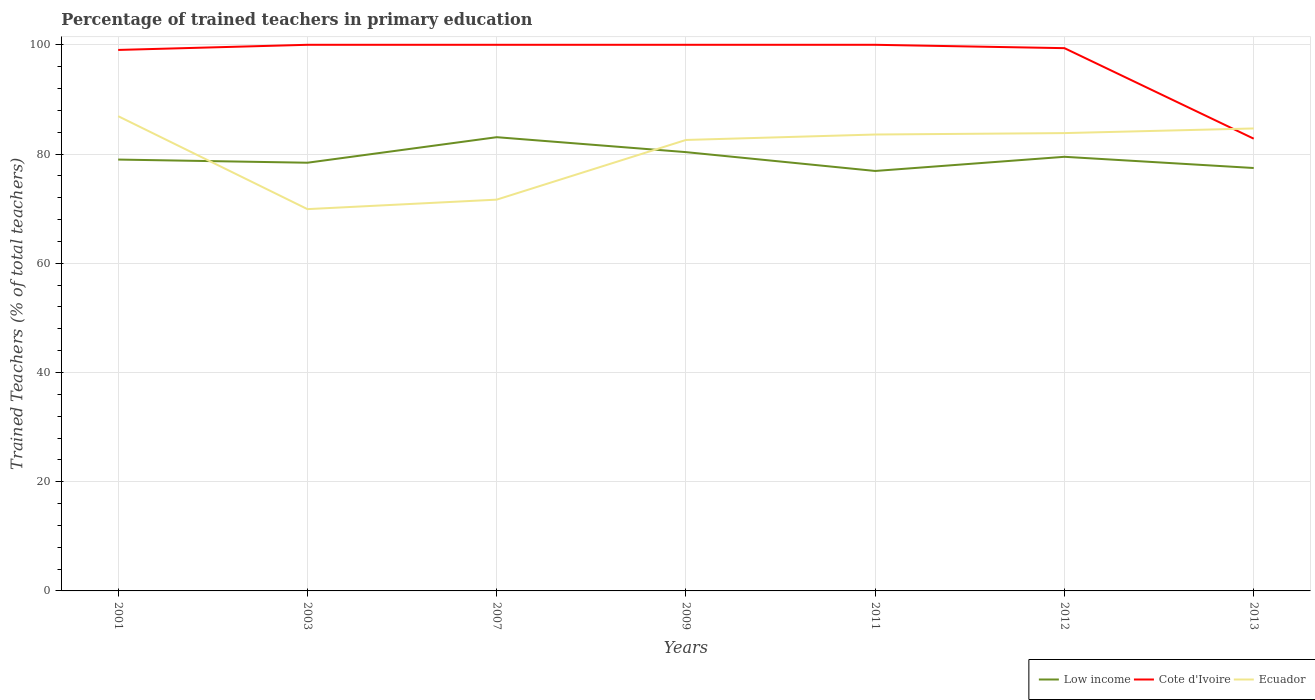Does the line corresponding to Ecuador intersect with the line corresponding to Cote d'Ivoire?
Provide a succinct answer. Yes. Is the number of lines equal to the number of legend labels?
Your answer should be very brief. Yes. Across all years, what is the maximum percentage of trained teachers in Low income?
Your response must be concise. 76.9. What is the total percentage of trained teachers in Ecuador in the graph?
Provide a succinct answer. -10.93. What is the difference between the highest and the second highest percentage of trained teachers in Cote d'Ivoire?
Your answer should be compact. 17.19. What is the difference between the highest and the lowest percentage of trained teachers in Low income?
Provide a succinct answer. 3. Is the percentage of trained teachers in Ecuador strictly greater than the percentage of trained teachers in Low income over the years?
Your answer should be very brief. No. How many years are there in the graph?
Make the answer very short. 7. Are the values on the major ticks of Y-axis written in scientific E-notation?
Provide a short and direct response. No. Does the graph contain any zero values?
Your answer should be compact. No. How are the legend labels stacked?
Ensure brevity in your answer.  Horizontal. What is the title of the graph?
Make the answer very short. Percentage of trained teachers in primary education. Does "Caribbean small states" appear as one of the legend labels in the graph?
Give a very brief answer. No. What is the label or title of the Y-axis?
Provide a succinct answer. Trained Teachers (% of total teachers). What is the Trained Teachers (% of total teachers) in Low income in 2001?
Offer a very short reply. 78.98. What is the Trained Teachers (% of total teachers) of Cote d'Ivoire in 2001?
Give a very brief answer. 99.06. What is the Trained Teachers (% of total teachers) of Ecuador in 2001?
Provide a short and direct response. 86.93. What is the Trained Teachers (% of total teachers) in Low income in 2003?
Give a very brief answer. 78.41. What is the Trained Teachers (% of total teachers) in Cote d'Ivoire in 2003?
Give a very brief answer. 100. What is the Trained Teachers (% of total teachers) of Ecuador in 2003?
Provide a short and direct response. 69.91. What is the Trained Teachers (% of total teachers) of Low income in 2007?
Offer a very short reply. 83.08. What is the Trained Teachers (% of total teachers) of Ecuador in 2007?
Keep it short and to the point. 71.65. What is the Trained Teachers (% of total teachers) in Low income in 2009?
Provide a succinct answer. 80.35. What is the Trained Teachers (% of total teachers) in Cote d'Ivoire in 2009?
Provide a succinct answer. 100. What is the Trained Teachers (% of total teachers) of Ecuador in 2009?
Keep it short and to the point. 82.57. What is the Trained Teachers (% of total teachers) in Low income in 2011?
Offer a very short reply. 76.9. What is the Trained Teachers (% of total teachers) of Cote d'Ivoire in 2011?
Offer a very short reply. 100. What is the Trained Teachers (% of total teachers) of Ecuador in 2011?
Provide a succinct answer. 83.57. What is the Trained Teachers (% of total teachers) of Low income in 2012?
Make the answer very short. 79.49. What is the Trained Teachers (% of total teachers) in Cote d'Ivoire in 2012?
Make the answer very short. 99.38. What is the Trained Teachers (% of total teachers) of Ecuador in 2012?
Your answer should be very brief. 83.83. What is the Trained Teachers (% of total teachers) in Low income in 2013?
Provide a short and direct response. 77.44. What is the Trained Teachers (% of total teachers) of Cote d'Ivoire in 2013?
Your answer should be very brief. 82.81. What is the Trained Teachers (% of total teachers) of Ecuador in 2013?
Offer a terse response. 84.68. Across all years, what is the maximum Trained Teachers (% of total teachers) in Low income?
Provide a succinct answer. 83.08. Across all years, what is the maximum Trained Teachers (% of total teachers) of Ecuador?
Your answer should be very brief. 86.93. Across all years, what is the minimum Trained Teachers (% of total teachers) in Low income?
Your response must be concise. 76.9. Across all years, what is the minimum Trained Teachers (% of total teachers) in Cote d'Ivoire?
Ensure brevity in your answer.  82.81. Across all years, what is the minimum Trained Teachers (% of total teachers) of Ecuador?
Provide a short and direct response. 69.91. What is the total Trained Teachers (% of total teachers) of Low income in the graph?
Give a very brief answer. 554.64. What is the total Trained Teachers (% of total teachers) in Cote d'Ivoire in the graph?
Keep it short and to the point. 681.25. What is the total Trained Teachers (% of total teachers) in Ecuador in the graph?
Provide a short and direct response. 563.14. What is the difference between the Trained Teachers (% of total teachers) of Low income in 2001 and that in 2003?
Offer a very short reply. 0.58. What is the difference between the Trained Teachers (% of total teachers) in Cote d'Ivoire in 2001 and that in 2003?
Provide a short and direct response. -0.94. What is the difference between the Trained Teachers (% of total teachers) in Ecuador in 2001 and that in 2003?
Offer a terse response. 17.02. What is the difference between the Trained Teachers (% of total teachers) in Low income in 2001 and that in 2007?
Keep it short and to the point. -4.1. What is the difference between the Trained Teachers (% of total teachers) in Cote d'Ivoire in 2001 and that in 2007?
Offer a very short reply. -0.94. What is the difference between the Trained Teachers (% of total teachers) of Ecuador in 2001 and that in 2007?
Provide a short and direct response. 15.28. What is the difference between the Trained Teachers (% of total teachers) of Low income in 2001 and that in 2009?
Offer a terse response. -1.36. What is the difference between the Trained Teachers (% of total teachers) in Cote d'Ivoire in 2001 and that in 2009?
Offer a very short reply. -0.94. What is the difference between the Trained Teachers (% of total teachers) of Ecuador in 2001 and that in 2009?
Provide a succinct answer. 4.35. What is the difference between the Trained Teachers (% of total teachers) in Low income in 2001 and that in 2011?
Offer a terse response. 2.09. What is the difference between the Trained Teachers (% of total teachers) in Cote d'Ivoire in 2001 and that in 2011?
Your response must be concise. -0.94. What is the difference between the Trained Teachers (% of total teachers) of Ecuador in 2001 and that in 2011?
Provide a succinct answer. 3.36. What is the difference between the Trained Teachers (% of total teachers) in Low income in 2001 and that in 2012?
Ensure brevity in your answer.  -0.51. What is the difference between the Trained Teachers (% of total teachers) in Cote d'Ivoire in 2001 and that in 2012?
Keep it short and to the point. -0.33. What is the difference between the Trained Teachers (% of total teachers) in Ecuador in 2001 and that in 2012?
Give a very brief answer. 3.1. What is the difference between the Trained Teachers (% of total teachers) of Low income in 2001 and that in 2013?
Offer a terse response. 1.55. What is the difference between the Trained Teachers (% of total teachers) of Cote d'Ivoire in 2001 and that in 2013?
Your answer should be compact. 16.25. What is the difference between the Trained Teachers (% of total teachers) in Ecuador in 2001 and that in 2013?
Your answer should be very brief. 2.25. What is the difference between the Trained Teachers (% of total teachers) in Low income in 2003 and that in 2007?
Offer a terse response. -4.68. What is the difference between the Trained Teachers (% of total teachers) of Ecuador in 2003 and that in 2007?
Your response must be concise. -1.74. What is the difference between the Trained Teachers (% of total teachers) of Low income in 2003 and that in 2009?
Offer a terse response. -1.94. What is the difference between the Trained Teachers (% of total teachers) of Ecuador in 2003 and that in 2009?
Offer a very short reply. -12.66. What is the difference between the Trained Teachers (% of total teachers) of Low income in 2003 and that in 2011?
Offer a terse response. 1.51. What is the difference between the Trained Teachers (% of total teachers) of Cote d'Ivoire in 2003 and that in 2011?
Your response must be concise. 0. What is the difference between the Trained Teachers (% of total teachers) in Ecuador in 2003 and that in 2011?
Keep it short and to the point. -13.66. What is the difference between the Trained Teachers (% of total teachers) of Low income in 2003 and that in 2012?
Provide a short and direct response. -1.09. What is the difference between the Trained Teachers (% of total teachers) of Cote d'Ivoire in 2003 and that in 2012?
Your answer should be compact. 0.62. What is the difference between the Trained Teachers (% of total teachers) in Ecuador in 2003 and that in 2012?
Offer a terse response. -13.92. What is the difference between the Trained Teachers (% of total teachers) in Low income in 2003 and that in 2013?
Make the answer very short. 0.97. What is the difference between the Trained Teachers (% of total teachers) in Cote d'Ivoire in 2003 and that in 2013?
Your answer should be very brief. 17.19. What is the difference between the Trained Teachers (% of total teachers) in Ecuador in 2003 and that in 2013?
Your answer should be compact. -14.77. What is the difference between the Trained Teachers (% of total teachers) of Low income in 2007 and that in 2009?
Offer a very short reply. 2.74. What is the difference between the Trained Teachers (% of total teachers) in Ecuador in 2007 and that in 2009?
Make the answer very short. -10.93. What is the difference between the Trained Teachers (% of total teachers) in Low income in 2007 and that in 2011?
Your response must be concise. 6.18. What is the difference between the Trained Teachers (% of total teachers) in Cote d'Ivoire in 2007 and that in 2011?
Make the answer very short. 0. What is the difference between the Trained Teachers (% of total teachers) in Ecuador in 2007 and that in 2011?
Offer a terse response. -11.93. What is the difference between the Trained Teachers (% of total teachers) of Low income in 2007 and that in 2012?
Make the answer very short. 3.59. What is the difference between the Trained Teachers (% of total teachers) of Cote d'Ivoire in 2007 and that in 2012?
Your response must be concise. 0.62. What is the difference between the Trained Teachers (% of total teachers) of Ecuador in 2007 and that in 2012?
Your response must be concise. -12.19. What is the difference between the Trained Teachers (% of total teachers) in Low income in 2007 and that in 2013?
Ensure brevity in your answer.  5.64. What is the difference between the Trained Teachers (% of total teachers) of Cote d'Ivoire in 2007 and that in 2013?
Provide a succinct answer. 17.19. What is the difference between the Trained Teachers (% of total teachers) in Ecuador in 2007 and that in 2013?
Make the answer very short. -13.04. What is the difference between the Trained Teachers (% of total teachers) in Low income in 2009 and that in 2011?
Ensure brevity in your answer.  3.45. What is the difference between the Trained Teachers (% of total teachers) in Ecuador in 2009 and that in 2011?
Your answer should be compact. -1. What is the difference between the Trained Teachers (% of total teachers) in Low income in 2009 and that in 2012?
Provide a short and direct response. 0.85. What is the difference between the Trained Teachers (% of total teachers) of Cote d'Ivoire in 2009 and that in 2012?
Your answer should be very brief. 0.62. What is the difference between the Trained Teachers (% of total teachers) of Ecuador in 2009 and that in 2012?
Provide a succinct answer. -1.26. What is the difference between the Trained Teachers (% of total teachers) in Low income in 2009 and that in 2013?
Make the answer very short. 2.91. What is the difference between the Trained Teachers (% of total teachers) of Cote d'Ivoire in 2009 and that in 2013?
Provide a short and direct response. 17.19. What is the difference between the Trained Teachers (% of total teachers) of Ecuador in 2009 and that in 2013?
Ensure brevity in your answer.  -2.11. What is the difference between the Trained Teachers (% of total teachers) in Low income in 2011 and that in 2012?
Provide a short and direct response. -2.59. What is the difference between the Trained Teachers (% of total teachers) of Cote d'Ivoire in 2011 and that in 2012?
Make the answer very short. 0.62. What is the difference between the Trained Teachers (% of total teachers) in Ecuador in 2011 and that in 2012?
Your answer should be compact. -0.26. What is the difference between the Trained Teachers (% of total teachers) of Low income in 2011 and that in 2013?
Provide a succinct answer. -0.54. What is the difference between the Trained Teachers (% of total teachers) of Cote d'Ivoire in 2011 and that in 2013?
Ensure brevity in your answer.  17.19. What is the difference between the Trained Teachers (% of total teachers) in Ecuador in 2011 and that in 2013?
Ensure brevity in your answer.  -1.11. What is the difference between the Trained Teachers (% of total teachers) in Low income in 2012 and that in 2013?
Ensure brevity in your answer.  2.05. What is the difference between the Trained Teachers (% of total teachers) of Cote d'Ivoire in 2012 and that in 2013?
Make the answer very short. 16.58. What is the difference between the Trained Teachers (% of total teachers) of Ecuador in 2012 and that in 2013?
Your answer should be compact. -0.85. What is the difference between the Trained Teachers (% of total teachers) of Low income in 2001 and the Trained Teachers (% of total teachers) of Cote d'Ivoire in 2003?
Your response must be concise. -21.02. What is the difference between the Trained Teachers (% of total teachers) in Low income in 2001 and the Trained Teachers (% of total teachers) in Ecuador in 2003?
Keep it short and to the point. 9.07. What is the difference between the Trained Teachers (% of total teachers) in Cote d'Ivoire in 2001 and the Trained Teachers (% of total teachers) in Ecuador in 2003?
Offer a terse response. 29.15. What is the difference between the Trained Teachers (% of total teachers) in Low income in 2001 and the Trained Teachers (% of total teachers) in Cote d'Ivoire in 2007?
Make the answer very short. -21.02. What is the difference between the Trained Teachers (% of total teachers) of Low income in 2001 and the Trained Teachers (% of total teachers) of Ecuador in 2007?
Give a very brief answer. 7.34. What is the difference between the Trained Teachers (% of total teachers) of Cote d'Ivoire in 2001 and the Trained Teachers (% of total teachers) of Ecuador in 2007?
Offer a terse response. 27.41. What is the difference between the Trained Teachers (% of total teachers) of Low income in 2001 and the Trained Teachers (% of total teachers) of Cote d'Ivoire in 2009?
Give a very brief answer. -21.02. What is the difference between the Trained Teachers (% of total teachers) in Low income in 2001 and the Trained Teachers (% of total teachers) in Ecuador in 2009?
Your answer should be very brief. -3.59. What is the difference between the Trained Teachers (% of total teachers) in Cote d'Ivoire in 2001 and the Trained Teachers (% of total teachers) in Ecuador in 2009?
Offer a very short reply. 16.48. What is the difference between the Trained Teachers (% of total teachers) of Low income in 2001 and the Trained Teachers (% of total teachers) of Cote d'Ivoire in 2011?
Offer a very short reply. -21.02. What is the difference between the Trained Teachers (% of total teachers) of Low income in 2001 and the Trained Teachers (% of total teachers) of Ecuador in 2011?
Provide a succinct answer. -4.59. What is the difference between the Trained Teachers (% of total teachers) in Cote d'Ivoire in 2001 and the Trained Teachers (% of total teachers) in Ecuador in 2011?
Give a very brief answer. 15.48. What is the difference between the Trained Teachers (% of total teachers) of Low income in 2001 and the Trained Teachers (% of total teachers) of Cote d'Ivoire in 2012?
Provide a succinct answer. -20.4. What is the difference between the Trained Teachers (% of total teachers) in Low income in 2001 and the Trained Teachers (% of total teachers) in Ecuador in 2012?
Your response must be concise. -4.85. What is the difference between the Trained Teachers (% of total teachers) of Cote d'Ivoire in 2001 and the Trained Teachers (% of total teachers) of Ecuador in 2012?
Offer a terse response. 15.23. What is the difference between the Trained Teachers (% of total teachers) of Low income in 2001 and the Trained Teachers (% of total teachers) of Cote d'Ivoire in 2013?
Make the answer very short. -3.82. What is the difference between the Trained Teachers (% of total teachers) in Low income in 2001 and the Trained Teachers (% of total teachers) in Ecuador in 2013?
Provide a short and direct response. -5.7. What is the difference between the Trained Teachers (% of total teachers) in Cote d'Ivoire in 2001 and the Trained Teachers (% of total teachers) in Ecuador in 2013?
Your answer should be very brief. 14.38. What is the difference between the Trained Teachers (% of total teachers) in Low income in 2003 and the Trained Teachers (% of total teachers) in Cote d'Ivoire in 2007?
Give a very brief answer. -21.59. What is the difference between the Trained Teachers (% of total teachers) of Low income in 2003 and the Trained Teachers (% of total teachers) of Ecuador in 2007?
Your answer should be compact. 6.76. What is the difference between the Trained Teachers (% of total teachers) of Cote d'Ivoire in 2003 and the Trained Teachers (% of total teachers) of Ecuador in 2007?
Offer a very short reply. 28.35. What is the difference between the Trained Teachers (% of total teachers) in Low income in 2003 and the Trained Teachers (% of total teachers) in Cote d'Ivoire in 2009?
Keep it short and to the point. -21.59. What is the difference between the Trained Teachers (% of total teachers) in Low income in 2003 and the Trained Teachers (% of total teachers) in Ecuador in 2009?
Your answer should be very brief. -4.17. What is the difference between the Trained Teachers (% of total teachers) of Cote d'Ivoire in 2003 and the Trained Teachers (% of total teachers) of Ecuador in 2009?
Ensure brevity in your answer.  17.43. What is the difference between the Trained Teachers (% of total teachers) of Low income in 2003 and the Trained Teachers (% of total teachers) of Cote d'Ivoire in 2011?
Keep it short and to the point. -21.59. What is the difference between the Trained Teachers (% of total teachers) in Low income in 2003 and the Trained Teachers (% of total teachers) in Ecuador in 2011?
Make the answer very short. -5.17. What is the difference between the Trained Teachers (% of total teachers) in Cote d'Ivoire in 2003 and the Trained Teachers (% of total teachers) in Ecuador in 2011?
Your response must be concise. 16.43. What is the difference between the Trained Teachers (% of total teachers) in Low income in 2003 and the Trained Teachers (% of total teachers) in Cote d'Ivoire in 2012?
Make the answer very short. -20.98. What is the difference between the Trained Teachers (% of total teachers) in Low income in 2003 and the Trained Teachers (% of total teachers) in Ecuador in 2012?
Your answer should be compact. -5.43. What is the difference between the Trained Teachers (% of total teachers) in Cote d'Ivoire in 2003 and the Trained Teachers (% of total teachers) in Ecuador in 2012?
Your response must be concise. 16.17. What is the difference between the Trained Teachers (% of total teachers) of Low income in 2003 and the Trained Teachers (% of total teachers) of Cote d'Ivoire in 2013?
Offer a very short reply. -4.4. What is the difference between the Trained Teachers (% of total teachers) of Low income in 2003 and the Trained Teachers (% of total teachers) of Ecuador in 2013?
Your answer should be compact. -6.28. What is the difference between the Trained Teachers (% of total teachers) of Cote d'Ivoire in 2003 and the Trained Teachers (% of total teachers) of Ecuador in 2013?
Ensure brevity in your answer.  15.32. What is the difference between the Trained Teachers (% of total teachers) of Low income in 2007 and the Trained Teachers (% of total teachers) of Cote d'Ivoire in 2009?
Provide a succinct answer. -16.92. What is the difference between the Trained Teachers (% of total teachers) of Low income in 2007 and the Trained Teachers (% of total teachers) of Ecuador in 2009?
Make the answer very short. 0.51. What is the difference between the Trained Teachers (% of total teachers) in Cote d'Ivoire in 2007 and the Trained Teachers (% of total teachers) in Ecuador in 2009?
Provide a succinct answer. 17.43. What is the difference between the Trained Teachers (% of total teachers) in Low income in 2007 and the Trained Teachers (% of total teachers) in Cote d'Ivoire in 2011?
Provide a succinct answer. -16.92. What is the difference between the Trained Teachers (% of total teachers) of Low income in 2007 and the Trained Teachers (% of total teachers) of Ecuador in 2011?
Your answer should be very brief. -0.49. What is the difference between the Trained Teachers (% of total teachers) in Cote d'Ivoire in 2007 and the Trained Teachers (% of total teachers) in Ecuador in 2011?
Give a very brief answer. 16.43. What is the difference between the Trained Teachers (% of total teachers) of Low income in 2007 and the Trained Teachers (% of total teachers) of Cote d'Ivoire in 2012?
Provide a succinct answer. -16.3. What is the difference between the Trained Teachers (% of total teachers) in Low income in 2007 and the Trained Teachers (% of total teachers) in Ecuador in 2012?
Provide a short and direct response. -0.75. What is the difference between the Trained Teachers (% of total teachers) in Cote d'Ivoire in 2007 and the Trained Teachers (% of total teachers) in Ecuador in 2012?
Offer a very short reply. 16.17. What is the difference between the Trained Teachers (% of total teachers) in Low income in 2007 and the Trained Teachers (% of total teachers) in Cote d'Ivoire in 2013?
Ensure brevity in your answer.  0.27. What is the difference between the Trained Teachers (% of total teachers) in Low income in 2007 and the Trained Teachers (% of total teachers) in Ecuador in 2013?
Your answer should be compact. -1.6. What is the difference between the Trained Teachers (% of total teachers) of Cote d'Ivoire in 2007 and the Trained Teachers (% of total teachers) of Ecuador in 2013?
Make the answer very short. 15.32. What is the difference between the Trained Teachers (% of total teachers) of Low income in 2009 and the Trained Teachers (% of total teachers) of Cote d'Ivoire in 2011?
Your answer should be very brief. -19.65. What is the difference between the Trained Teachers (% of total teachers) of Low income in 2009 and the Trained Teachers (% of total teachers) of Ecuador in 2011?
Offer a terse response. -3.23. What is the difference between the Trained Teachers (% of total teachers) of Cote d'Ivoire in 2009 and the Trained Teachers (% of total teachers) of Ecuador in 2011?
Keep it short and to the point. 16.43. What is the difference between the Trained Teachers (% of total teachers) of Low income in 2009 and the Trained Teachers (% of total teachers) of Cote d'Ivoire in 2012?
Give a very brief answer. -19.04. What is the difference between the Trained Teachers (% of total teachers) in Low income in 2009 and the Trained Teachers (% of total teachers) in Ecuador in 2012?
Offer a very short reply. -3.49. What is the difference between the Trained Teachers (% of total teachers) in Cote d'Ivoire in 2009 and the Trained Teachers (% of total teachers) in Ecuador in 2012?
Ensure brevity in your answer.  16.17. What is the difference between the Trained Teachers (% of total teachers) of Low income in 2009 and the Trained Teachers (% of total teachers) of Cote d'Ivoire in 2013?
Ensure brevity in your answer.  -2.46. What is the difference between the Trained Teachers (% of total teachers) in Low income in 2009 and the Trained Teachers (% of total teachers) in Ecuador in 2013?
Your answer should be very brief. -4.34. What is the difference between the Trained Teachers (% of total teachers) of Cote d'Ivoire in 2009 and the Trained Teachers (% of total teachers) of Ecuador in 2013?
Your answer should be compact. 15.32. What is the difference between the Trained Teachers (% of total teachers) in Low income in 2011 and the Trained Teachers (% of total teachers) in Cote d'Ivoire in 2012?
Ensure brevity in your answer.  -22.49. What is the difference between the Trained Teachers (% of total teachers) in Low income in 2011 and the Trained Teachers (% of total teachers) in Ecuador in 2012?
Your response must be concise. -6.93. What is the difference between the Trained Teachers (% of total teachers) in Cote d'Ivoire in 2011 and the Trained Teachers (% of total teachers) in Ecuador in 2012?
Your response must be concise. 16.17. What is the difference between the Trained Teachers (% of total teachers) of Low income in 2011 and the Trained Teachers (% of total teachers) of Cote d'Ivoire in 2013?
Your answer should be compact. -5.91. What is the difference between the Trained Teachers (% of total teachers) of Low income in 2011 and the Trained Teachers (% of total teachers) of Ecuador in 2013?
Make the answer very short. -7.78. What is the difference between the Trained Teachers (% of total teachers) in Cote d'Ivoire in 2011 and the Trained Teachers (% of total teachers) in Ecuador in 2013?
Your answer should be very brief. 15.32. What is the difference between the Trained Teachers (% of total teachers) in Low income in 2012 and the Trained Teachers (% of total teachers) in Cote d'Ivoire in 2013?
Provide a short and direct response. -3.32. What is the difference between the Trained Teachers (% of total teachers) of Low income in 2012 and the Trained Teachers (% of total teachers) of Ecuador in 2013?
Provide a short and direct response. -5.19. What is the difference between the Trained Teachers (% of total teachers) of Cote d'Ivoire in 2012 and the Trained Teachers (% of total teachers) of Ecuador in 2013?
Ensure brevity in your answer.  14.7. What is the average Trained Teachers (% of total teachers) of Low income per year?
Offer a very short reply. 79.23. What is the average Trained Teachers (% of total teachers) of Cote d'Ivoire per year?
Your answer should be very brief. 97.32. What is the average Trained Teachers (% of total teachers) of Ecuador per year?
Make the answer very short. 80.45. In the year 2001, what is the difference between the Trained Teachers (% of total teachers) in Low income and Trained Teachers (% of total teachers) in Cote d'Ivoire?
Offer a very short reply. -20.07. In the year 2001, what is the difference between the Trained Teachers (% of total teachers) of Low income and Trained Teachers (% of total teachers) of Ecuador?
Offer a terse response. -7.94. In the year 2001, what is the difference between the Trained Teachers (% of total teachers) of Cote d'Ivoire and Trained Teachers (% of total teachers) of Ecuador?
Your answer should be compact. 12.13. In the year 2003, what is the difference between the Trained Teachers (% of total teachers) in Low income and Trained Teachers (% of total teachers) in Cote d'Ivoire?
Ensure brevity in your answer.  -21.59. In the year 2003, what is the difference between the Trained Teachers (% of total teachers) in Low income and Trained Teachers (% of total teachers) in Ecuador?
Your answer should be compact. 8.5. In the year 2003, what is the difference between the Trained Teachers (% of total teachers) in Cote d'Ivoire and Trained Teachers (% of total teachers) in Ecuador?
Provide a succinct answer. 30.09. In the year 2007, what is the difference between the Trained Teachers (% of total teachers) in Low income and Trained Teachers (% of total teachers) in Cote d'Ivoire?
Your response must be concise. -16.92. In the year 2007, what is the difference between the Trained Teachers (% of total teachers) of Low income and Trained Teachers (% of total teachers) of Ecuador?
Your response must be concise. 11.44. In the year 2007, what is the difference between the Trained Teachers (% of total teachers) in Cote d'Ivoire and Trained Teachers (% of total teachers) in Ecuador?
Provide a short and direct response. 28.35. In the year 2009, what is the difference between the Trained Teachers (% of total teachers) in Low income and Trained Teachers (% of total teachers) in Cote d'Ivoire?
Provide a succinct answer. -19.65. In the year 2009, what is the difference between the Trained Teachers (% of total teachers) of Low income and Trained Teachers (% of total teachers) of Ecuador?
Make the answer very short. -2.23. In the year 2009, what is the difference between the Trained Teachers (% of total teachers) in Cote d'Ivoire and Trained Teachers (% of total teachers) in Ecuador?
Provide a succinct answer. 17.43. In the year 2011, what is the difference between the Trained Teachers (% of total teachers) of Low income and Trained Teachers (% of total teachers) of Cote d'Ivoire?
Ensure brevity in your answer.  -23.1. In the year 2011, what is the difference between the Trained Teachers (% of total teachers) in Low income and Trained Teachers (% of total teachers) in Ecuador?
Provide a short and direct response. -6.67. In the year 2011, what is the difference between the Trained Teachers (% of total teachers) in Cote d'Ivoire and Trained Teachers (% of total teachers) in Ecuador?
Make the answer very short. 16.43. In the year 2012, what is the difference between the Trained Teachers (% of total teachers) in Low income and Trained Teachers (% of total teachers) in Cote d'Ivoire?
Your answer should be very brief. -19.89. In the year 2012, what is the difference between the Trained Teachers (% of total teachers) of Low income and Trained Teachers (% of total teachers) of Ecuador?
Offer a very short reply. -4.34. In the year 2012, what is the difference between the Trained Teachers (% of total teachers) in Cote d'Ivoire and Trained Teachers (% of total teachers) in Ecuador?
Your answer should be compact. 15.55. In the year 2013, what is the difference between the Trained Teachers (% of total teachers) of Low income and Trained Teachers (% of total teachers) of Cote d'Ivoire?
Provide a succinct answer. -5.37. In the year 2013, what is the difference between the Trained Teachers (% of total teachers) of Low income and Trained Teachers (% of total teachers) of Ecuador?
Your answer should be compact. -7.24. In the year 2013, what is the difference between the Trained Teachers (% of total teachers) of Cote d'Ivoire and Trained Teachers (% of total teachers) of Ecuador?
Ensure brevity in your answer.  -1.87. What is the ratio of the Trained Teachers (% of total teachers) in Low income in 2001 to that in 2003?
Make the answer very short. 1.01. What is the ratio of the Trained Teachers (% of total teachers) of Cote d'Ivoire in 2001 to that in 2003?
Provide a succinct answer. 0.99. What is the ratio of the Trained Teachers (% of total teachers) in Ecuador in 2001 to that in 2003?
Offer a terse response. 1.24. What is the ratio of the Trained Teachers (% of total teachers) of Low income in 2001 to that in 2007?
Provide a succinct answer. 0.95. What is the ratio of the Trained Teachers (% of total teachers) of Cote d'Ivoire in 2001 to that in 2007?
Your answer should be compact. 0.99. What is the ratio of the Trained Teachers (% of total teachers) of Ecuador in 2001 to that in 2007?
Give a very brief answer. 1.21. What is the ratio of the Trained Teachers (% of total teachers) of Low income in 2001 to that in 2009?
Keep it short and to the point. 0.98. What is the ratio of the Trained Teachers (% of total teachers) of Cote d'Ivoire in 2001 to that in 2009?
Your answer should be compact. 0.99. What is the ratio of the Trained Teachers (% of total teachers) in Ecuador in 2001 to that in 2009?
Your response must be concise. 1.05. What is the ratio of the Trained Teachers (% of total teachers) in Low income in 2001 to that in 2011?
Ensure brevity in your answer.  1.03. What is the ratio of the Trained Teachers (% of total teachers) of Cote d'Ivoire in 2001 to that in 2011?
Give a very brief answer. 0.99. What is the ratio of the Trained Teachers (% of total teachers) of Ecuador in 2001 to that in 2011?
Ensure brevity in your answer.  1.04. What is the ratio of the Trained Teachers (% of total teachers) of Low income in 2001 to that in 2012?
Your answer should be very brief. 0.99. What is the ratio of the Trained Teachers (% of total teachers) of Cote d'Ivoire in 2001 to that in 2012?
Give a very brief answer. 1. What is the ratio of the Trained Teachers (% of total teachers) of Ecuador in 2001 to that in 2012?
Make the answer very short. 1.04. What is the ratio of the Trained Teachers (% of total teachers) of Cote d'Ivoire in 2001 to that in 2013?
Keep it short and to the point. 1.2. What is the ratio of the Trained Teachers (% of total teachers) in Ecuador in 2001 to that in 2013?
Make the answer very short. 1.03. What is the ratio of the Trained Teachers (% of total teachers) in Low income in 2003 to that in 2007?
Give a very brief answer. 0.94. What is the ratio of the Trained Teachers (% of total teachers) of Ecuador in 2003 to that in 2007?
Offer a terse response. 0.98. What is the ratio of the Trained Teachers (% of total teachers) of Low income in 2003 to that in 2009?
Make the answer very short. 0.98. What is the ratio of the Trained Teachers (% of total teachers) of Cote d'Ivoire in 2003 to that in 2009?
Your answer should be compact. 1. What is the ratio of the Trained Teachers (% of total teachers) in Ecuador in 2003 to that in 2009?
Offer a terse response. 0.85. What is the ratio of the Trained Teachers (% of total teachers) in Low income in 2003 to that in 2011?
Your answer should be very brief. 1.02. What is the ratio of the Trained Teachers (% of total teachers) in Ecuador in 2003 to that in 2011?
Offer a terse response. 0.84. What is the ratio of the Trained Teachers (% of total teachers) in Low income in 2003 to that in 2012?
Provide a succinct answer. 0.99. What is the ratio of the Trained Teachers (% of total teachers) in Ecuador in 2003 to that in 2012?
Ensure brevity in your answer.  0.83. What is the ratio of the Trained Teachers (% of total teachers) in Low income in 2003 to that in 2013?
Give a very brief answer. 1.01. What is the ratio of the Trained Teachers (% of total teachers) of Cote d'Ivoire in 2003 to that in 2013?
Give a very brief answer. 1.21. What is the ratio of the Trained Teachers (% of total teachers) of Ecuador in 2003 to that in 2013?
Your response must be concise. 0.83. What is the ratio of the Trained Teachers (% of total teachers) of Low income in 2007 to that in 2009?
Make the answer very short. 1.03. What is the ratio of the Trained Teachers (% of total teachers) in Cote d'Ivoire in 2007 to that in 2009?
Provide a short and direct response. 1. What is the ratio of the Trained Teachers (% of total teachers) of Ecuador in 2007 to that in 2009?
Provide a short and direct response. 0.87. What is the ratio of the Trained Teachers (% of total teachers) in Low income in 2007 to that in 2011?
Ensure brevity in your answer.  1.08. What is the ratio of the Trained Teachers (% of total teachers) in Ecuador in 2007 to that in 2011?
Your answer should be very brief. 0.86. What is the ratio of the Trained Teachers (% of total teachers) of Low income in 2007 to that in 2012?
Give a very brief answer. 1.05. What is the ratio of the Trained Teachers (% of total teachers) of Ecuador in 2007 to that in 2012?
Make the answer very short. 0.85. What is the ratio of the Trained Teachers (% of total teachers) of Low income in 2007 to that in 2013?
Your answer should be very brief. 1.07. What is the ratio of the Trained Teachers (% of total teachers) of Cote d'Ivoire in 2007 to that in 2013?
Make the answer very short. 1.21. What is the ratio of the Trained Teachers (% of total teachers) of Ecuador in 2007 to that in 2013?
Your response must be concise. 0.85. What is the ratio of the Trained Teachers (% of total teachers) in Low income in 2009 to that in 2011?
Make the answer very short. 1.04. What is the ratio of the Trained Teachers (% of total teachers) of Ecuador in 2009 to that in 2011?
Offer a terse response. 0.99. What is the ratio of the Trained Teachers (% of total teachers) in Low income in 2009 to that in 2012?
Provide a short and direct response. 1.01. What is the ratio of the Trained Teachers (% of total teachers) in Low income in 2009 to that in 2013?
Give a very brief answer. 1.04. What is the ratio of the Trained Teachers (% of total teachers) in Cote d'Ivoire in 2009 to that in 2013?
Give a very brief answer. 1.21. What is the ratio of the Trained Teachers (% of total teachers) in Ecuador in 2009 to that in 2013?
Provide a succinct answer. 0.98. What is the ratio of the Trained Teachers (% of total teachers) in Low income in 2011 to that in 2012?
Offer a very short reply. 0.97. What is the ratio of the Trained Teachers (% of total teachers) of Cote d'Ivoire in 2011 to that in 2012?
Your response must be concise. 1.01. What is the ratio of the Trained Teachers (% of total teachers) in Low income in 2011 to that in 2013?
Provide a short and direct response. 0.99. What is the ratio of the Trained Teachers (% of total teachers) of Cote d'Ivoire in 2011 to that in 2013?
Your response must be concise. 1.21. What is the ratio of the Trained Teachers (% of total teachers) in Ecuador in 2011 to that in 2013?
Give a very brief answer. 0.99. What is the ratio of the Trained Teachers (% of total teachers) of Low income in 2012 to that in 2013?
Your answer should be very brief. 1.03. What is the ratio of the Trained Teachers (% of total teachers) of Cote d'Ivoire in 2012 to that in 2013?
Provide a short and direct response. 1.2. What is the difference between the highest and the second highest Trained Teachers (% of total teachers) of Low income?
Your answer should be very brief. 2.74. What is the difference between the highest and the second highest Trained Teachers (% of total teachers) in Cote d'Ivoire?
Provide a succinct answer. 0. What is the difference between the highest and the second highest Trained Teachers (% of total teachers) of Ecuador?
Give a very brief answer. 2.25. What is the difference between the highest and the lowest Trained Teachers (% of total teachers) in Low income?
Your answer should be compact. 6.18. What is the difference between the highest and the lowest Trained Teachers (% of total teachers) of Cote d'Ivoire?
Provide a short and direct response. 17.19. What is the difference between the highest and the lowest Trained Teachers (% of total teachers) in Ecuador?
Your answer should be very brief. 17.02. 